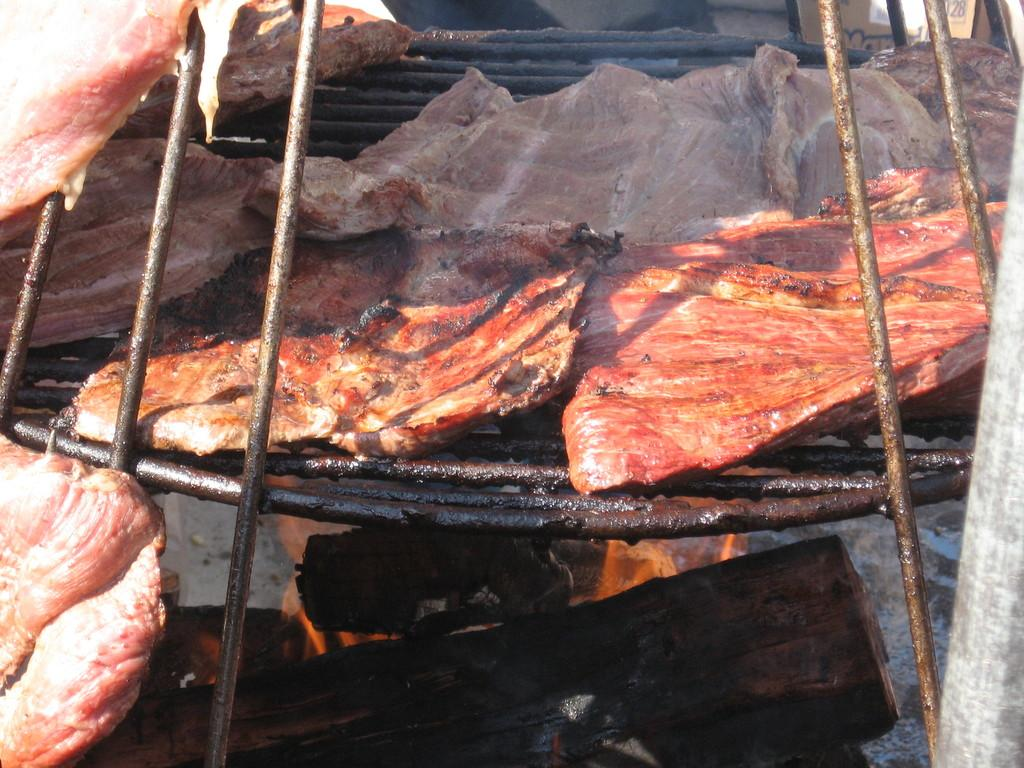What is being cooked on the grill in the image? There are slices of meat on a grill in the image. What type of fuel is being used for the fire in the image? Wooden logs are visible at the bottom of the image, suggesting that they are being used as fuel for the fire. Can you describe the fire in the image? Fire is present in the image. What type of pizzas are being served at the event in the image? There is no event or pizzas present in the image; it features slices of meat on a grill and wooden logs with fire. 